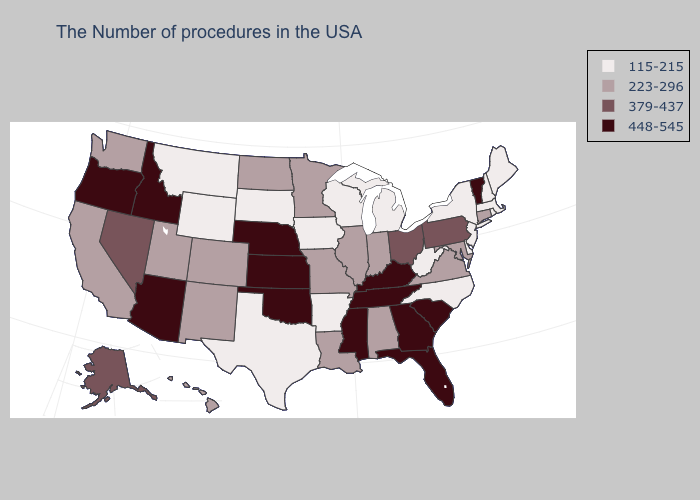Name the states that have a value in the range 115-215?
Quick response, please. Maine, Massachusetts, Rhode Island, New Hampshire, New York, New Jersey, Delaware, North Carolina, West Virginia, Michigan, Wisconsin, Arkansas, Iowa, Texas, South Dakota, Wyoming, Montana. Name the states that have a value in the range 448-545?
Short answer required. Vermont, South Carolina, Florida, Georgia, Kentucky, Tennessee, Mississippi, Kansas, Nebraska, Oklahoma, Arizona, Idaho, Oregon. Among the states that border Colorado , does Wyoming have the lowest value?
Keep it brief. Yes. What is the value of Alabama?
Answer briefly. 223-296. Does New Hampshire have the lowest value in the Northeast?
Concise answer only. Yes. What is the value of Florida?
Short answer required. 448-545. Does Arizona have the highest value in the West?
Short answer required. Yes. What is the value of Tennessee?
Concise answer only. 448-545. What is the value of Nevada?
Quick response, please. 379-437. Name the states that have a value in the range 379-437?
Be succinct. Pennsylvania, Ohio, Nevada, Alaska. Does Wyoming have the lowest value in the West?
Keep it brief. Yes. Name the states that have a value in the range 115-215?
Keep it brief. Maine, Massachusetts, Rhode Island, New Hampshire, New York, New Jersey, Delaware, North Carolina, West Virginia, Michigan, Wisconsin, Arkansas, Iowa, Texas, South Dakota, Wyoming, Montana. What is the value of Pennsylvania?
Be succinct. 379-437. Among the states that border Indiana , does Kentucky have the highest value?
Keep it brief. Yes. 